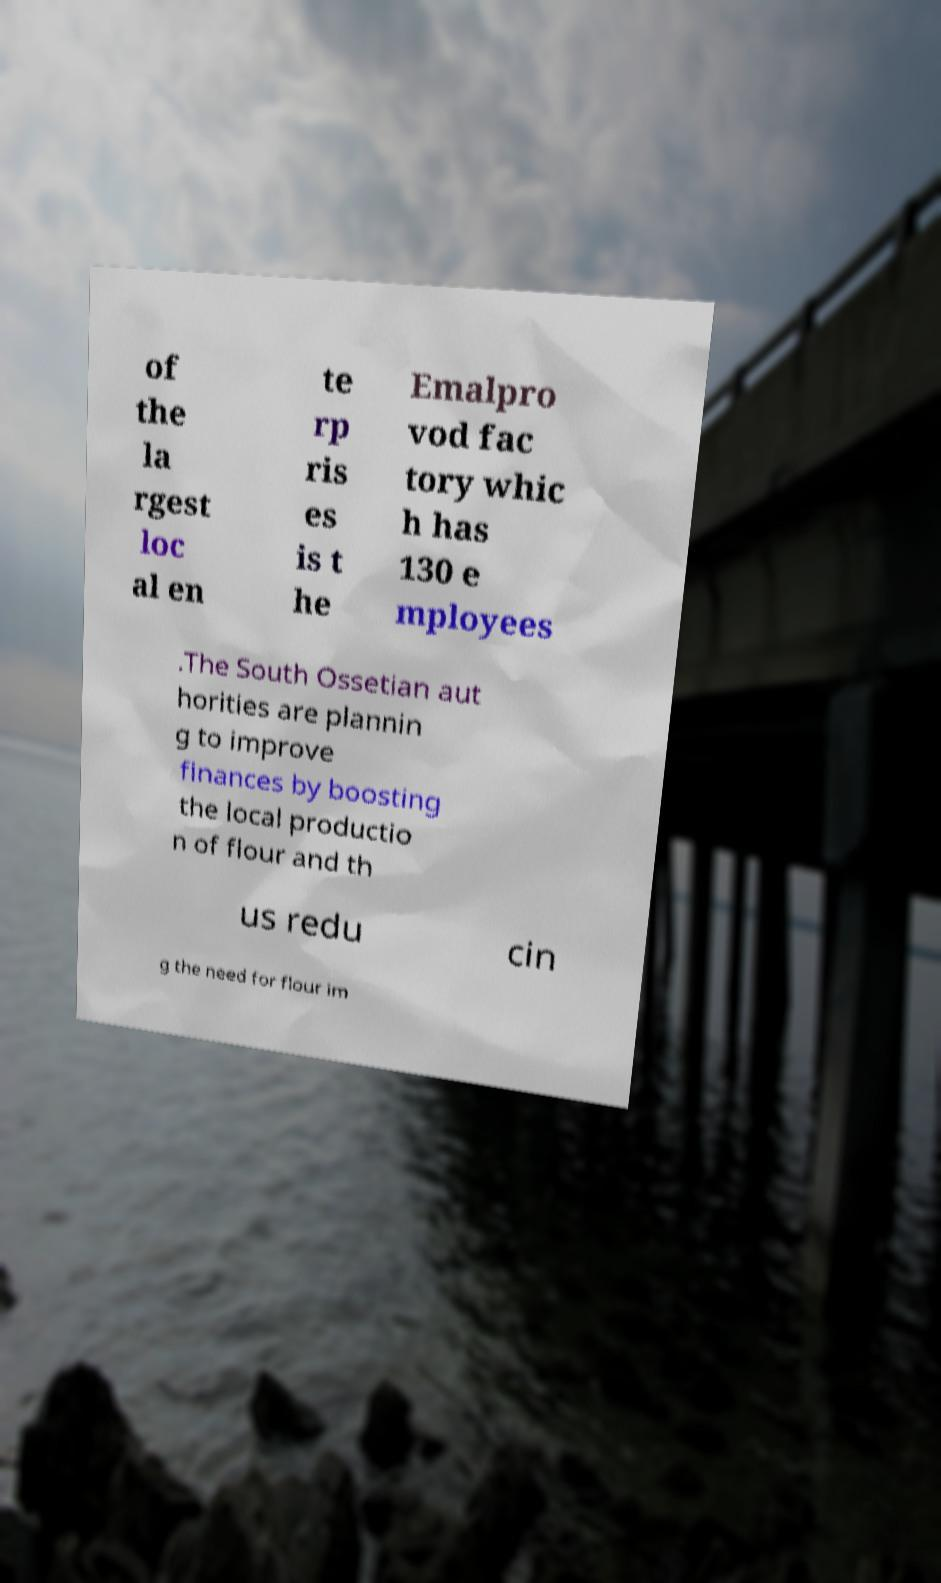What messages or text are displayed in this image? I need them in a readable, typed format. of the la rgest loc al en te rp ris es is t he Emalpro vod fac tory whic h has 130 e mployees .The South Ossetian aut horities are plannin g to improve finances by boosting the local productio n of flour and th us redu cin g the need for flour im 